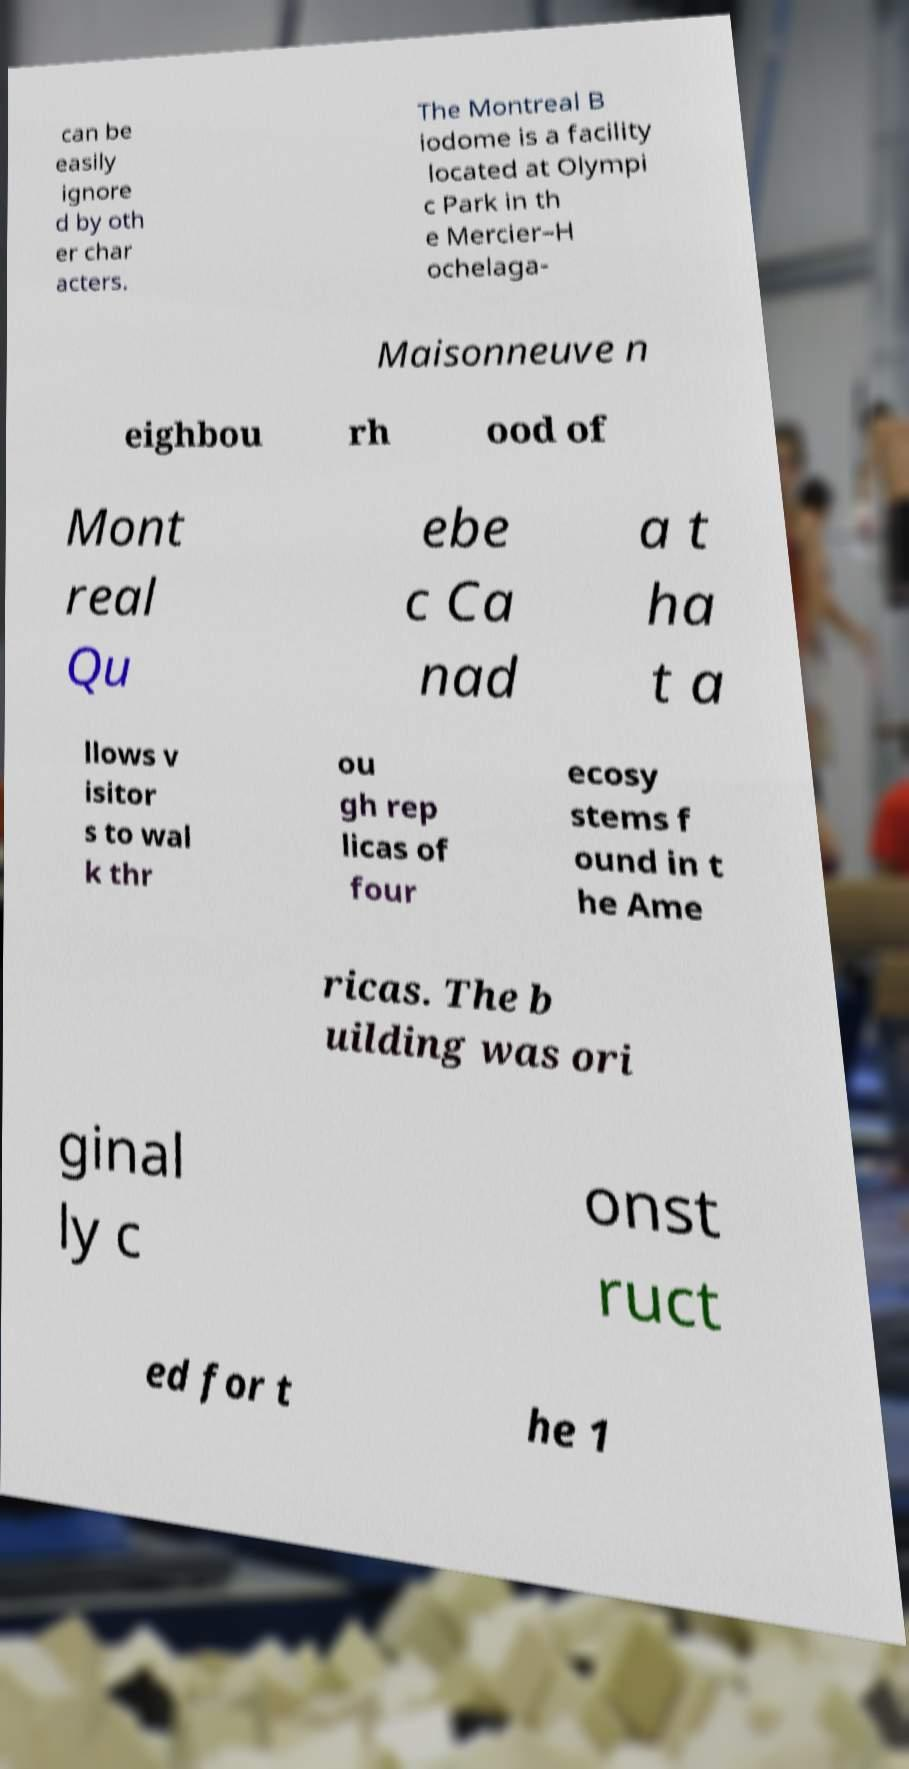Can you read and provide the text displayed in the image?This photo seems to have some interesting text. Can you extract and type it out for me? can be easily ignore d by oth er char acters. The Montreal B iodome is a facility located at Olympi c Park in th e Mercier–H ochelaga- Maisonneuve n eighbou rh ood of Mont real Qu ebe c Ca nad a t ha t a llows v isitor s to wal k thr ou gh rep licas of four ecosy stems f ound in t he Ame ricas. The b uilding was ori ginal ly c onst ruct ed for t he 1 